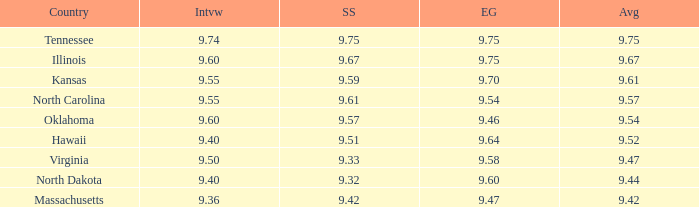What was the evening gown score when the swimsuit was 9.61? 9.54. 